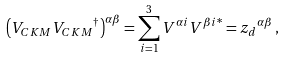<formula> <loc_0><loc_0><loc_500><loc_500>\left ( V _ { C K M } { V _ { C K M } } ^ { \dagger } \right ) ^ { \alpha \beta } = \sum _ { i = 1 } ^ { 3 } V ^ { \alpha i } { V ^ { \beta i } } ^ { \ast } = { z _ { d } } ^ { \alpha \beta } \, ,</formula> 